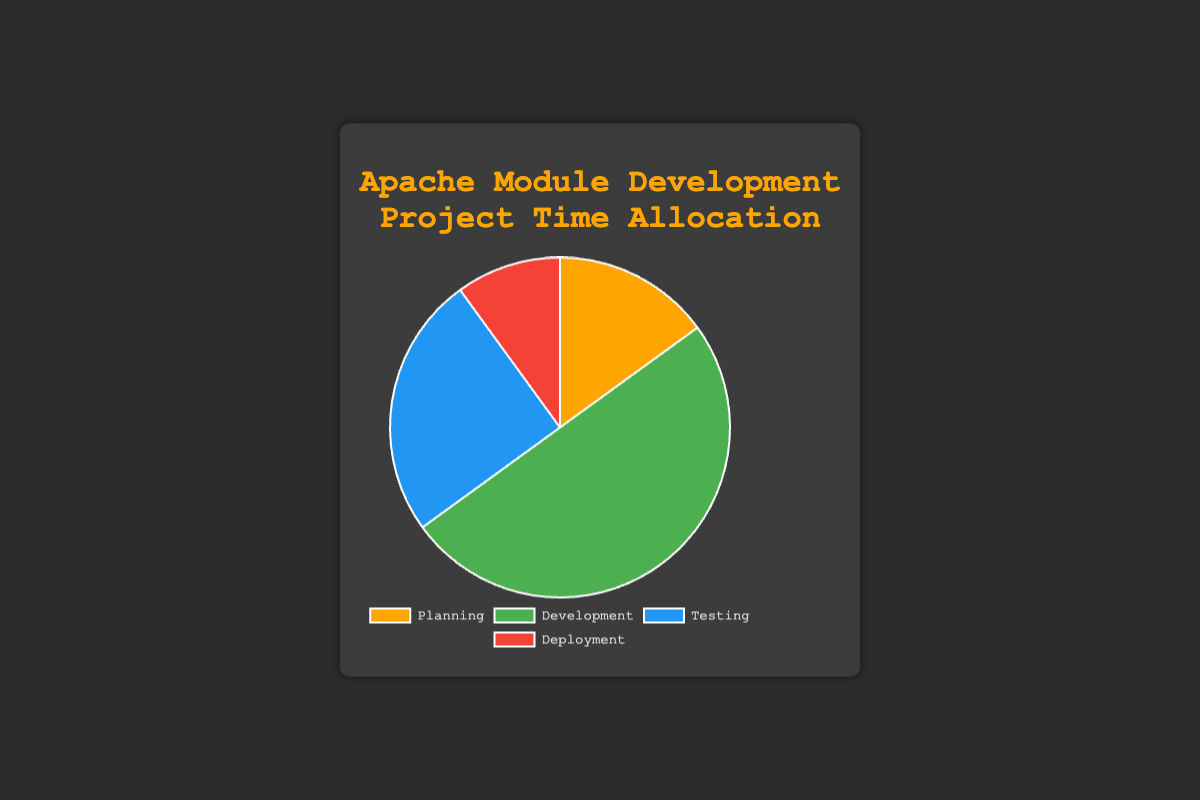Which project phase has the highest time allocation? The segment with the highest percentage represents the phase with the highest time allocation. The largest slice in the pie chart is labeled "Development" with 50%.
Answer: Development Which project phase has the lowest time allocation? The segment with the lowest percentage represents the phase with the lowest time allocation. The smallest slice in the pie chart is labeled "Deployment" with 10%.
Answer: Deployment What is the combined percentage of time allocated to Planning and Testing phases? Sum the percentages of Planning and Testing, which are 15% and 25% respectively. \( 15\% + 25\% = 40\% \)
Answer: 40% How much more time is allocated to Development compared to Deployment? Subtract the percentage of Deployment from Development. \( 50\% - 10\% = 40\% \)
Answer: 40% Are the Testing and Planning phases combined equal in time allocation to the Development phase? Calculate the combined percentage of Testing and Planning (15% + 25% = 40%). Compare this to the Development phase which is 50%. Since 40% is not equal to 50%, they are not equal.
Answer: No What is the average time allocation per phase? Sum the percentages of all phases and divide by the number of phases. \( (15\% + 50\% + 25\% + 10\%) / 4 = 25\% \)
Answer: 25% Which color represents the Testing phase in the pie chart? Look at the legend for the color label of Testing. The segment for Testing is labeled with the color blue.
Answer: Blue Is the time allocated for Deployment less than the time allocated for Testing? Compare Deployment (10%) with Testing (25%). Since 10% is less than 25%, the time allocated for Deployment is indeed less.
Answer: Yes What percentage of the total time is allocated to non-Development phases? Sum the percentages of Planning, Testing, and Deployment which are the non-Development phases: \( 15\% + 25\% + 10\% = 50\% \)
Answer: 50% If the total project time is 200 hours, how many hours are allocated to the Planning phase? Multiply the total project time by the Planning phase percentage: \( 200 \text{ hours} \times 15\% = 30 \text{ hours} \)
Answer: 30 hours 